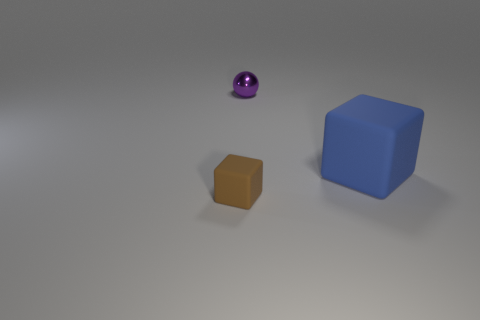Subtract all brown blocks. Subtract all brown spheres. How many blocks are left? 1 Add 1 big yellow shiny objects. How many objects exist? 4 Subtract all blocks. How many objects are left? 1 Subtract 0 red cylinders. How many objects are left? 3 Subtract all big red rubber things. Subtract all blue blocks. How many objects are left? 2 Add 2 purple metallic balls. How many purple metallic balls are left? 3 Add 2 metal balls. How many metal balls exist? 3 